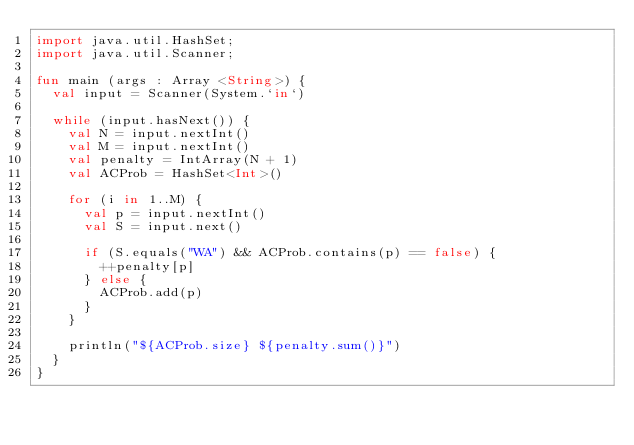<code> <loc_0><loc_0><loc_500><loc_500><_Kotlin_>import java.util.HashSet;
import java.util.Scanner;

fun main (args : Array <String>) {
  val input = Scanner(System.`in`)
  
  while (input.hasNext()) {
    val N = input.nextInt()
    val M = input.nextInt()
    val penalty = IntArray(N + 1)
    val ACProb = HashSet<Int>()
    
    for (i in 1..M) {
      val p = input.nextInt()
      val S = input.next()
      
      if (S.equals("WA") && ACProb.contains(p) == false) {
        ++penalty[p]
      } else {
        ACProb.add(p)
      }
    }
    
    println("${ACProb.size} ${penalty.sum()}")
  }
}</code> 